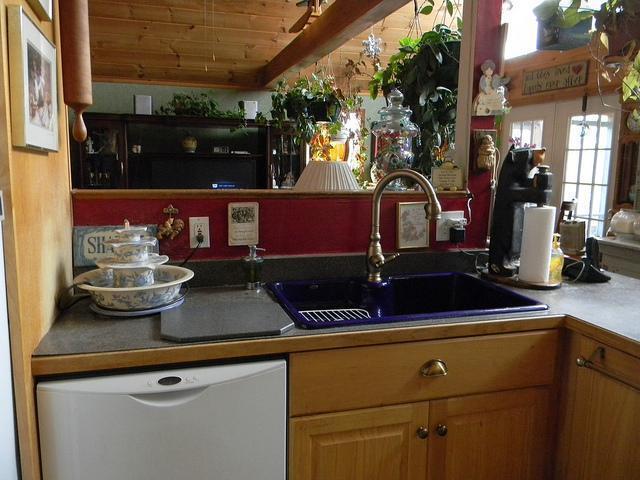What is on top of the counter?
Indicate the correct response by choosing from the four available options to answer the question.
Options: Banana, sink, cat, television. Sink. 